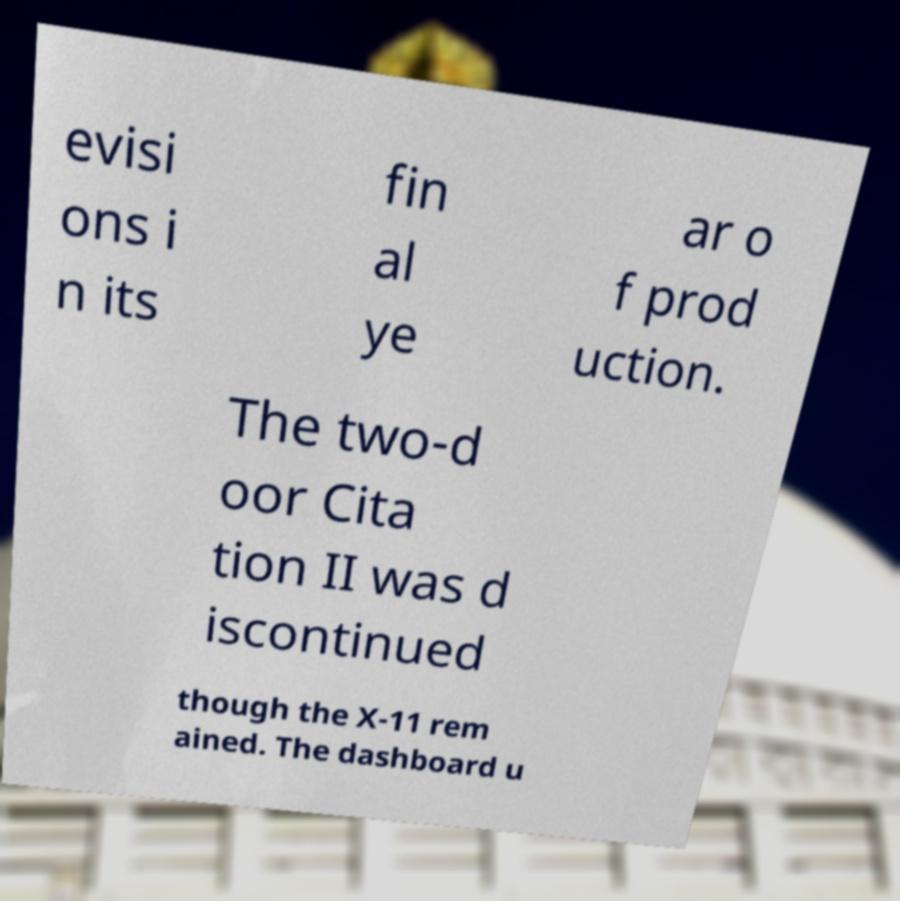Could you extract and type out the text from this image? evisi ons i n its fin al ye ar o f prod uction. The two-d oor Cita tion II was d iscontinued though the X-11 rem ained. The dashboard u 